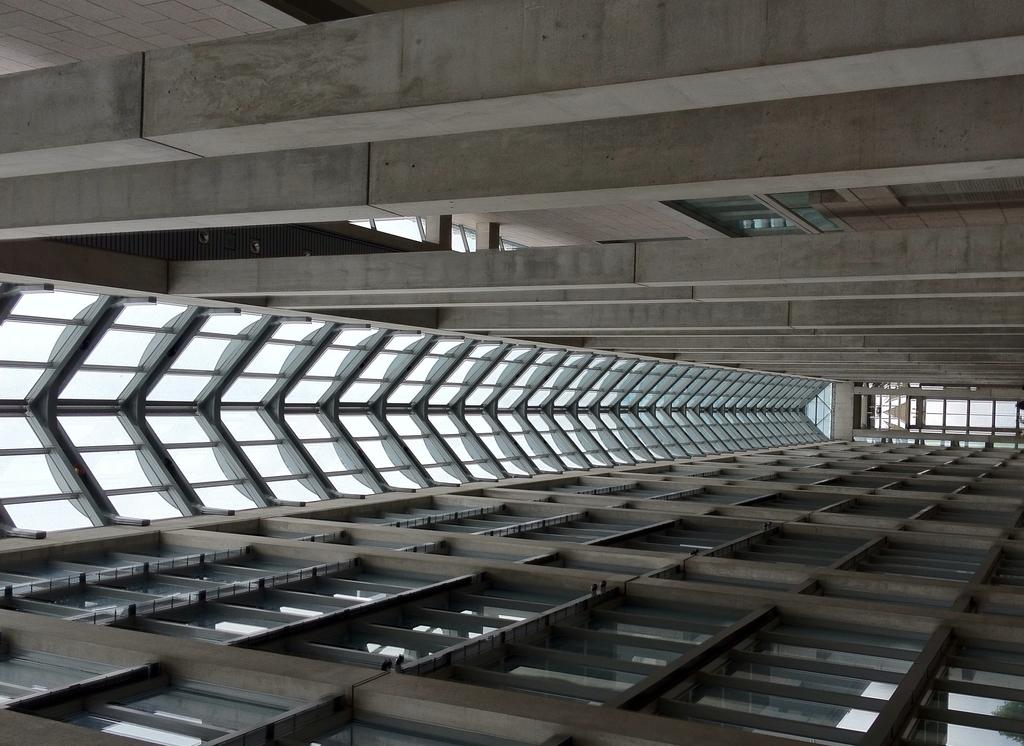What type of roof is visible in the image? There is a metal roof in the center of the image. Can you describe the material of the roof? The roof is made of metal. Where is the roof located in relation to the other elements in the image? The metal roof is in the center of the image. What type of bread can be seen in the image? There is no bread present in the image; it only features a metal roof. What knowledge can be gained from the image? The image provides information about the type of roof present, which is a metal roof. However, it does not convey any specific knowledge beyond that. 